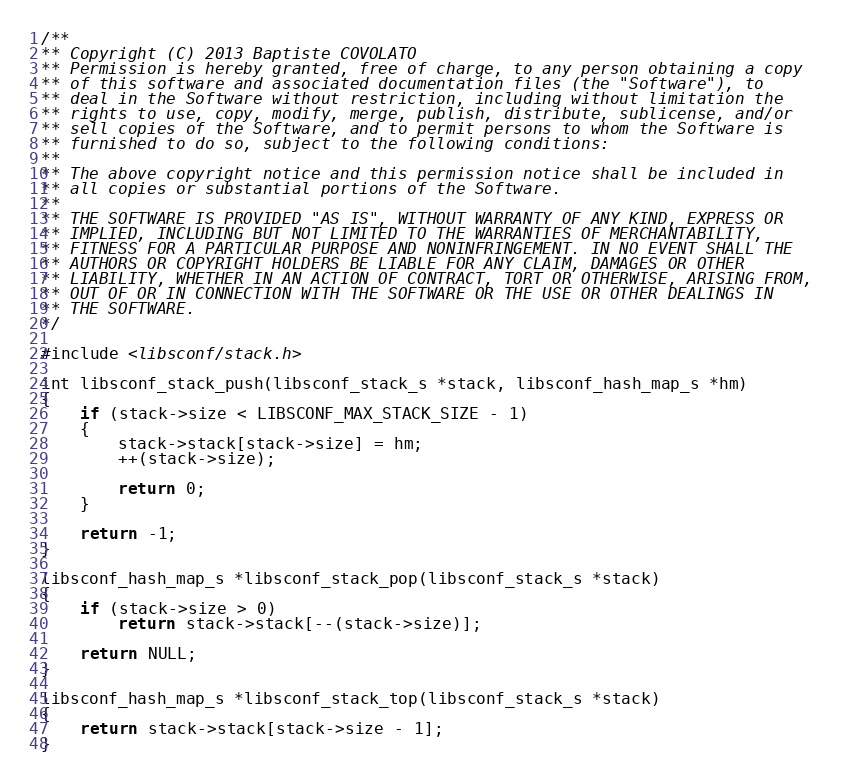<code> <loc_0><loc_0><loc_500><loc_500><_C_>/**
** Copyright (C) 2013 Baptiste COVOLATO
** Permission is hereby granted, free of charge, to any person obtaining a copy
** of this software and associated documentation files (the "Software"), to
** deal in the Software without restriction, including without limitation the
** rights to use, copy, modify, merge, publish, distribute, sublicense, and/or
** sell copies of the Software, and to permit persons to whom the Software is
** furnished to do so, subject to the following conditions:
**
** The above copyright notice and this permission notice shall be included in
** all copies or substantial portions of the Software.
**
** THE SOFTWARE IS PROVIDED "AS IS", WITHOUT WARRANTY OF ANY KIND, EXPRESS OR
** IMPLIED, INCLUDING BUT NOT LIMITED TO THE WARRANTIES OF MERCHANTABILITY,
** FITNESS FOR A PARTICULAR PURPOSE AND NONINFRINGEMENT. IN NO EVENT SHALL THE
** AUTHORS OR COPYRIGHT HOLDERS BE LIABLE FOR ANY CLAIM, DAMAGES OR OTHER
** LIABILITY, WHETHER IN AN ACTION OF CONTRACT, TORT OR OTHERWISE, ARISING FROM,
** OUT OF OR IN CONNECTION WITH THE SOFTWARE OR THE USE OR OTHER DEALINGS IN
** THE SOFTWARE.
*/

#include <libsconf/stack.h>

int libsconf_stack_push(libsconf_stack_s *stack, libsconf_hash_map_s *hm)
{
    if (stack->size < LIBSCONF_MAX_STACK_SIZE - 1)
    {
        stack->stack[stack->size] = hm;
        ++(stack->size);

        return 0;
    }

    return -1;
}

libsconf_hash_map_s *libsconf_stack_pop(libsconf_stack_s *stack)
{
    if (stack->size > 0)
        return stack->stack[--(stack->size)];

    return NULL;
}

libsconf_hash_map_s *libsconf_stack_top(libsconf_stack_s *stack)
{
    return stack->stack[stack->size - 1];
}
</code> 